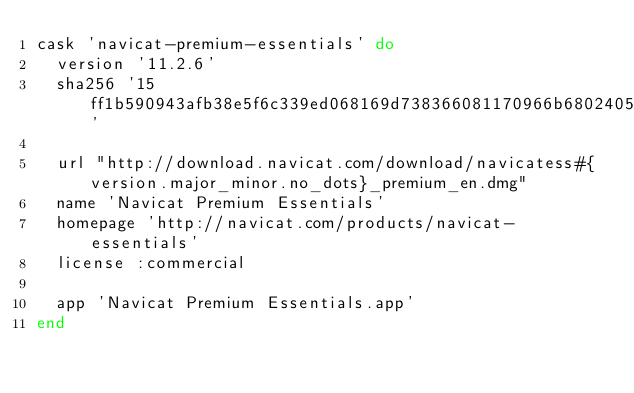Convert code to text. <code><loc_0><loc_0><loc_500><loc_500><_Ruby_>cask 'navicat-premium-essentials' do
  version '11.2.6'
  sha256 '15ff1b590943afb38e5f6c339ed068169d738366081170966b68024056d17685'

  url "http://download.navicat.com/download/navicatess#{version.major_minor.no_dots}_premium_en.dmg"
  name 'Navicat Premium Essentials'
  homepage 'http://navicat.com/products/navicat-essentials'
  license :commercial

  app 'Navicat Premium Essentials.app'
end
</code> 